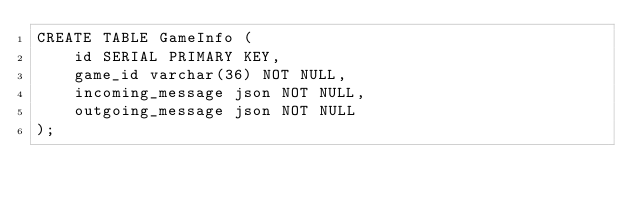Convert code to text. <code><loc_0><loc_0><loc_500><loc_500><_SQL_>CREATE TABLE GameInfo (
    id SERIAL PRIMARY KEY,
    game_id varchar(36) NOT NULL,
    incoming_message json NOT NULL,
    outgoing_message json NOT NULL
);</code> 